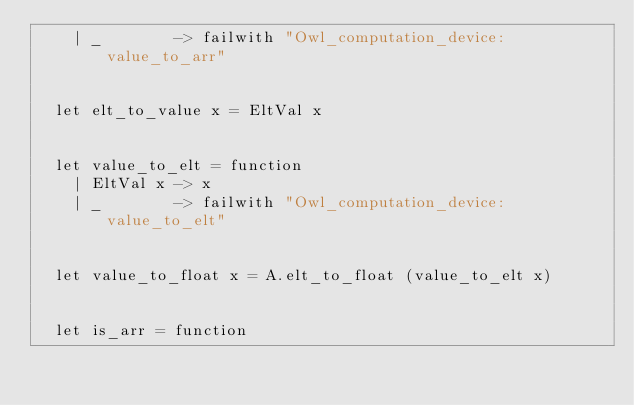Convert code to text. <code><loc_0><loc_0><loc_500><loc_500><_OCaml_>    | _        -> failwith "Owl_computation_device: value_to_arr"


  let elt_to_value x = EltVal x


  let value_to_elt = function
    | EltVal x -> x
    | _        -> failwith "Owl_computation_device: value_to_elt"


  let value_to_float x = A.elt_to_float (value_to_elt x)


  let is_arr = function</code> 